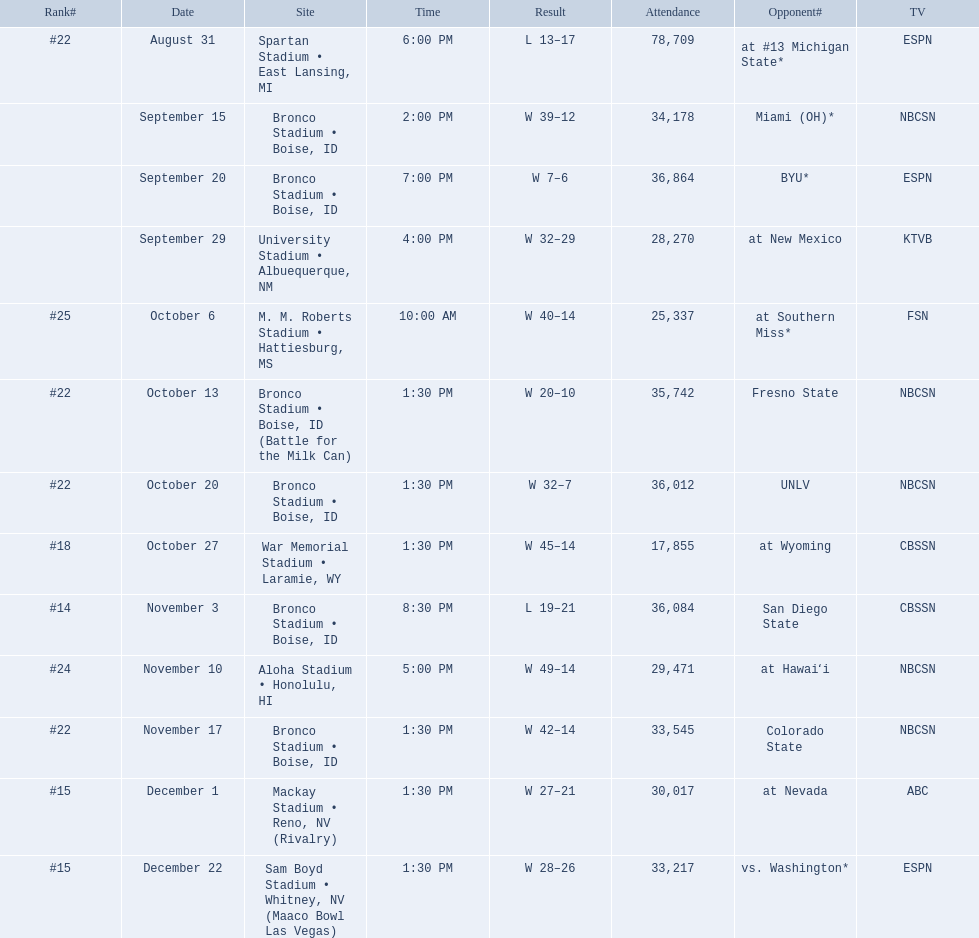Who were all of the opponents? At #13 michigan state*, miami (oh)*, byu*, at new mexico, at southern miss*, fresno state, unlv, at wyoming, san diego state, at hawaiʻi, colorado state, at nevada, vs. washington*. Who did they face on november 3rd? San Diego State. Would you be able to parse every entry in this table? {'header': ['Rank#', 'Date', 'Site', 'Time', 'Result', 'Attendance', 'Opponent#', 'TV'], 'rows': [['#22', 'August 31', 'Spartan Stadium • East Lansing, MI', '6:00 PM', 'L\xa013–17', '78,709', 'at\xa0#13\xa0Michigan State*', 'ESPN'], ['', 'September 15', 'Bronco Stadium • Boise, ID', '2:00 PM', 'W\xa039–12', '34,178', 'Miami (OH)*', 'NBCSN'], ['', 'September 20', 'Bronco Stadium • Boise, ID', '7:00 PM', 'W\xa07–6', '36,864', 'BYU*', 'ESPN'], ['', 'September 29', 'University Stadium • Albuequerque, NM', '4:00 PM', 'W\xa032–29', '28,270', 'at\xa0New Mexico', 'KTVB'], ['#25', 'October 6', 'M. M. Roberts Stadium • Hattiesburg, MS', '10:00 AM', 'W\xa040–14', '25,337', 'at\xa0Southern Miss*', 'FSN'], ['#22', 'October 13', 'Bronco Stadium • Boise, ID (Battle for the Milk Can)', '1:30 PM', 'W\xa020–10', '35,742', 'Fresno State', 'NBCSN'], ['#22', 'October 20', 'Bronco Stadium • Boise, ID', '1:30 PM', 'W\xa032–7', '36,012', 'UNLV', 'NBCSN'], ['#18', 'October 27', 'War Memorial Stadium • Laramie, WY', '1:30 PM', 'W\xa045–14', '17,855', 'at\xa0Wyoming', 'CBSSN'], ['#14', 'November 3', 'Bronco Stadium • Boise, ID', '8:30 PM', 'L\xa019–21', '36,084', 'San Diego State', 'CBSSN'], ['#24', 'November 10', 'Aloha Stadium • Honolulu, HI', '5:00 PM', 'W\xa049–14', '29,471', 'at\xa0Hawaiʻi', 'NBCSN'], ['#22', 'November 17', 'Bronco Stadium • Boise, ID', '1:30 PM', 'W\xa042–14', '33,545', 'Colorado State', 'NBCSN'], ['#15', 'December 1', 'Mackay Stadium • Reno, NV (Rivalry)', '1:30 PM', 'W\xa027–21', '30,017', 'at\xa0Nevada', 'ABC'], ['#15', 'December 22', 'Sam Boyd Stadium • Whitney, NV (Maaco Bowl Las Vegas)', '1:30 PM', 'W\xa028–26', '33,217', 'vs.\xa0Washington*', 'ESPN']]} What rank were they on november 3rd? #14. 